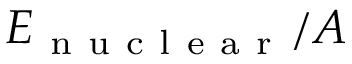<formula> <loc_0><loc_0><loc_500><loc_500>E _ { n u c l e a r } / A</formula> 